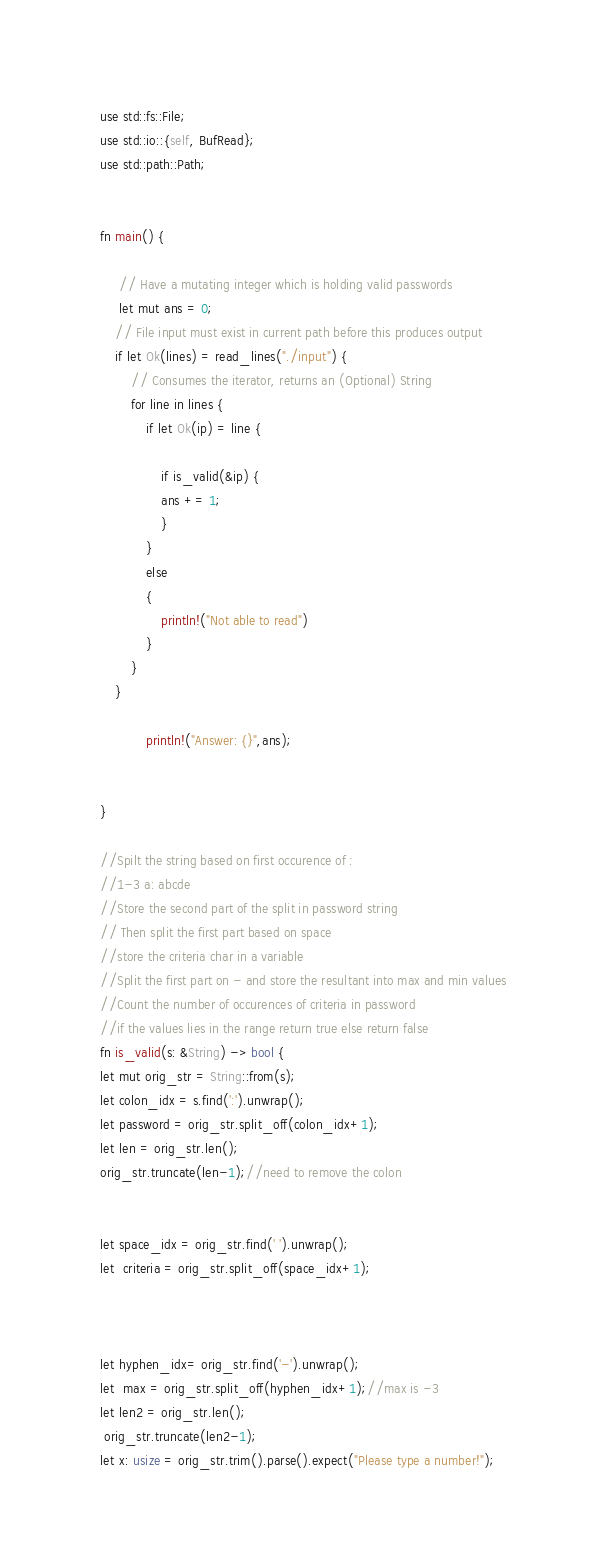<code> <loc_0><loc_0><loc_500><loc_500><_Rust_>use std::fs::File;
use std::io::{self, BufRead};
use std::path::Path;


fn main() {

     // Have a mutating integer which is holding valid passwords
     let mut ans = 0;
    // File input must exist in current path before this produces output
    if let Ok(lines) = read_lines("./input") {
        // Consumes the iterator, returns an (Optional) String
        for line in lines {
            if let Ok(ip) = line {
                
                if is_valid(&ip) {
                ans += 1;
                }
            }
            else
            {
            	println!("Not able to read")
            }
        }
    }

    		println!("Answer: {}",ans);

    	 
}

//Spilt the string based on first occurence of :
//1-3 a: abcde
//Store the second part of the split in password string
// Then split the first part based on space
//store the criteria char in a variable
//Split the first part on - and store the resultant into max and min values
//Count the number of occurences of criteria in password
//if the values lies in the range return true else return false
fn is_valid(s: &String) -> bool {
let mut orig_str = String::from(s);
let colon_idx = s.find(':').unwrap();
let password = orig_str.split_off(colon_idx+1);
let len = orig_str.len();
orig_str.truncate(len-1);//need to remove the colon


let space_idx = orig_str.find(' ').unwrap();
let  criteria = orig_str.split_off(space_idx+1);



let hyphen_idx= orig_str.find('-').unwrap();
let  max = orig_str.split_off(hyphen_idx+1);//max is -3
let len2 = orig_str.len();
 orig_str.truncate(len2-1);
let x: usize = orig_str.trim().parse().expect("Please type a number!");</code> 